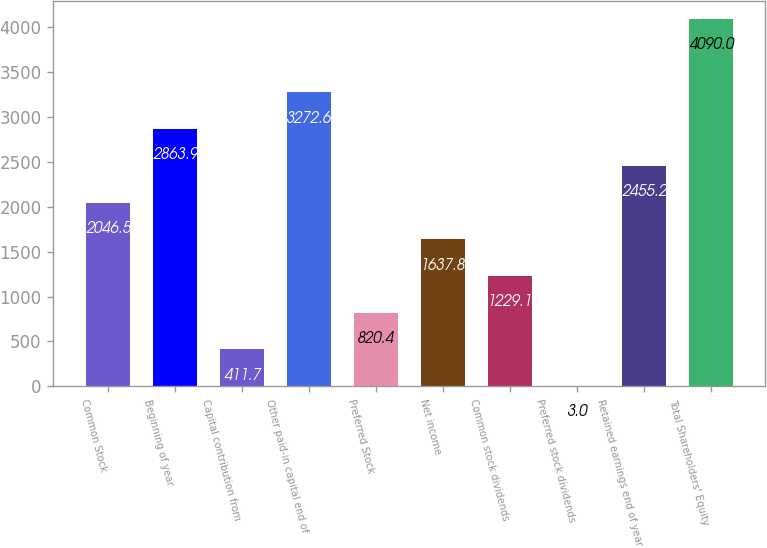Convert chart to OTSL. <chart><loc_0><loc_0><loc_500><loc_500><bar_chart><fcel>Common Stock<fcel>Beginning of year<fcel>Capital contribution from<fcel>Other paid-in capital end of<fcel>Preferred Stock<fcel>Net income<fcel>Common stock dividends<fcel>Preferred stock dividends<fcel>Retained earnings end of year<fcel>Total Shareholders' Equity<nl><fcel>2046.5<fcel>2863.9<fcel>411.7<fcel>3272.6<fcel>820.4<fcel>1637.8<fcel>1229.1<fcel>3<fcel>2455.2<fcel>4090<nl></chart> 